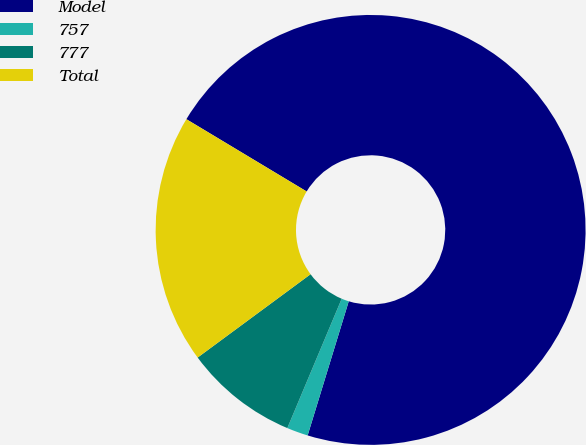Convert chart. <chart><loc_0><loc_0><loc_500><loc_500><pie_chart><fcel>Model<fcel>757<fcel>777<fcel>Total<nl><fcel>71.12%<fcel>1.6%<fcel>8.55%<fcel>18.73%<nl></chart> 